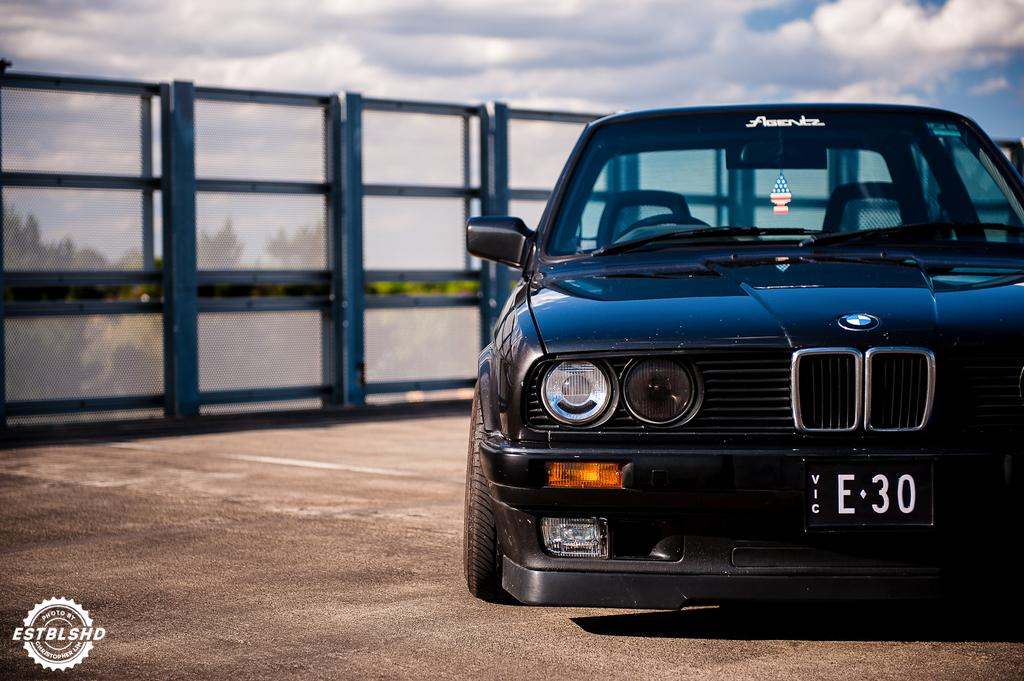What type of vehicle is in the image? There is a black car in the image. Where is the car located? The car is on a road. What can be seen in the background of the image? There is fencing and trees in the background of the image. What is visible in the sky at the top of the image? Clouds are visible in the sky at the top of the image. What type of underwear is hanging on the fencing in the image? There is no underwear present in the image; it only features a black car on a road with a background of fencing, trees, and clouds in the sky. 